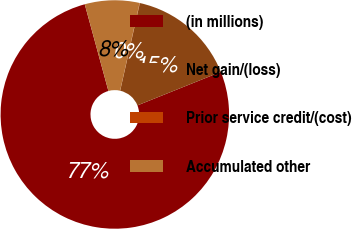Convert chart to OTSL. <chart><loc_0><loc_0><loc_500><loc_500><pie_chart><fcel>(in millions)<fcel>Net gain/(loss)<fcel>Prior service credit/(cost)<fcel>Accumulated other<nl><fcel>76.84%<fcel>15.4%<fcel>0.04%<fcel>7.72%<nl></chart> 